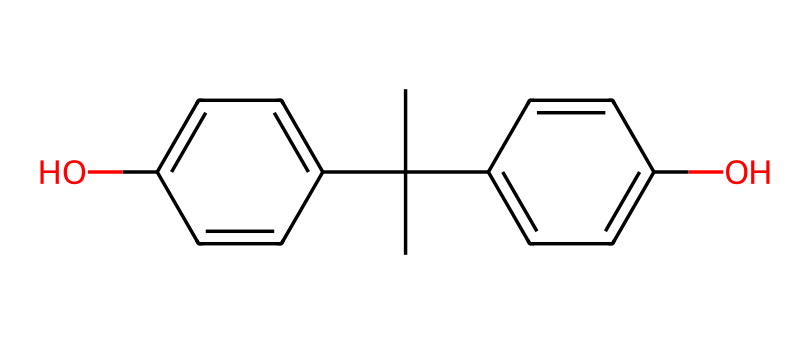What is the total number of carbon atoms in this compound? The SMILES representation indicates there are carbon atoms present, counted directly from the structure. In this case, the structure shows a total of 16 carbon atoms.
Answer: 16 How many hydroxyl (OH) groups are present in this compound? The structure contains two "O" atoms bonded with hydrogen, which indicates two hydroxyl functional groups. Thus, there are two OH groups.
Answer: 2 What type of compound is this based on its structure? The molecule consists of multiple aromatic rings and functional groups (hydroxyl), which characterizes it as a type of aromatic compound called a phenol.
Answer: phenol How many benzene rings are in the chemical structure? By analyzing the structure, there are two distinct aromatic rings visible within the chemical, corresponding to the presence of two benzene-like structures.
Answer: 2 Is this compound likely to be hydrophilic or hydrophobic? The presence of hydroxyl (OH) groups generally suggests that the compound will interact well with water, making it hydrophilic.
Answer: hydrophilic What is the highest degree of substitution present on a single carbon atom? Examining the structure, the carbon atom in the center appears to have three other carbon connections and two hydroxyl groups attached; thus, it features a maximum of five substituents.
Answer: 5 